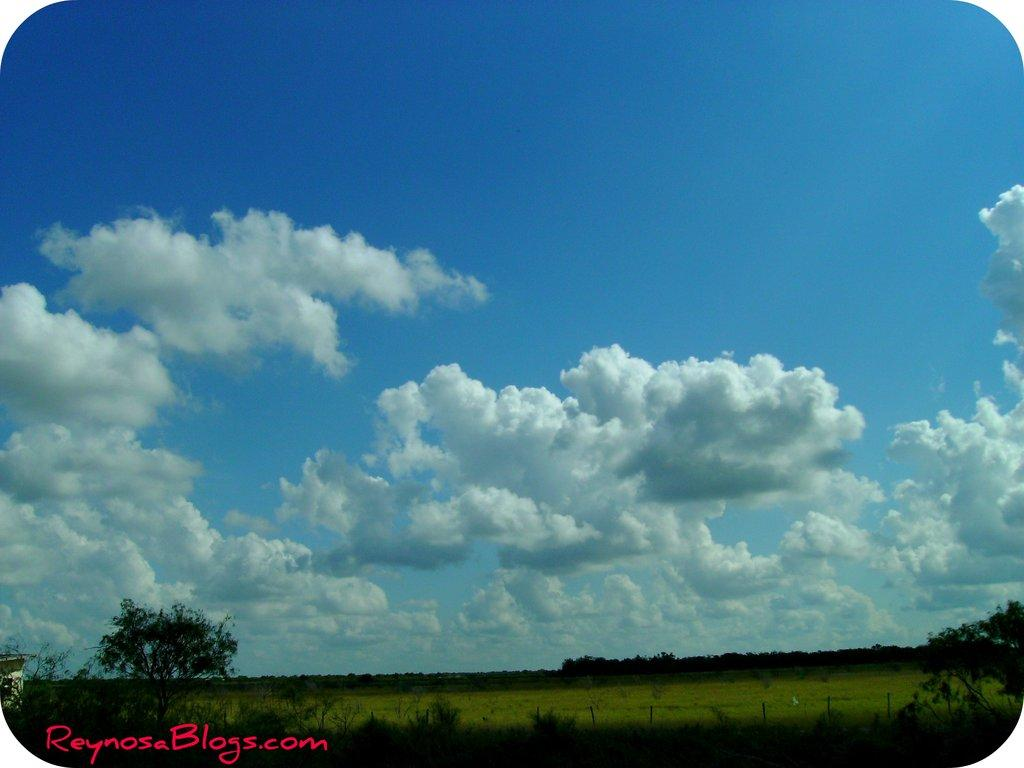What type of vegetation can be seen at the bottom of the image? There are trees, grass, and plants at the bottom of the image. What is visible in the background of the image? The sky is visible at the top of the image. Can you see a crowd of people gathered around the lake in the image? There is no lake or crowd of people present in the image. What type of squirrel can be seen climbing the tree in the image? There is no squirrel visible in the image; only trees, grass, plants, and sky are present. 